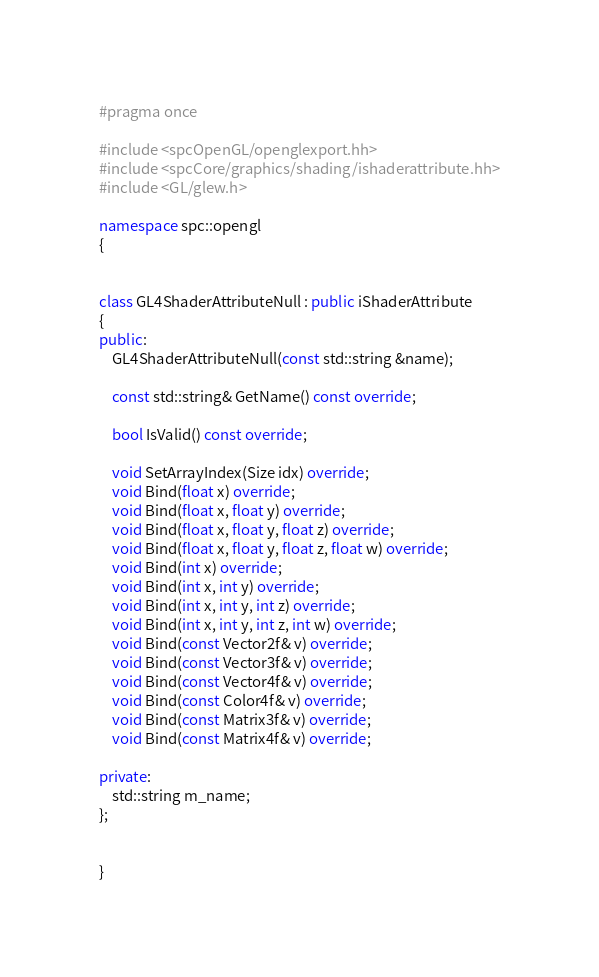Convert code to text. <code><loc_0><loc_0><loc_500><loc_500><_C++_>#pragma once

#include <spcOpenGL/openglexport.hh>
#include <spcCore/graphics/shading/ishaderattribute.hh>
#include <GL/glew.h>

namespace spc::opengl
{


class GL4ShaderAttributeNull : public iShaderAttribute
{
public:
	GL4ShaderAttributeNull(const std::string &name);

	const std::string& GetName() const override;

	bool IsValid() const override;

	void SetArrayIndex(Size idx) override;
	void Bind(float x) override;
	void Bind(float x, float y) override;
	void Bind(float x, float y, float z) override;
	void Bind(float x, float y, float z, float w) override;
	void Bind(int x) override;
	void Bind(int x, int y) override;
	void Bind(int x, int y, int z) override;
	void Bind(int x, int y, int z, int w) override;
	void Bind(const Vector2f& v) override;
	void Bind(const Vector3f& v) override;
	void Bind(const Vector4f& v) override;
	void Bind(const Color4f& v) override;
	void Bind(const Matrix3f& v) override;
	void Bind(const Matrix4f& v) override;

private:
	std::string m_name;
};


}

</code> 